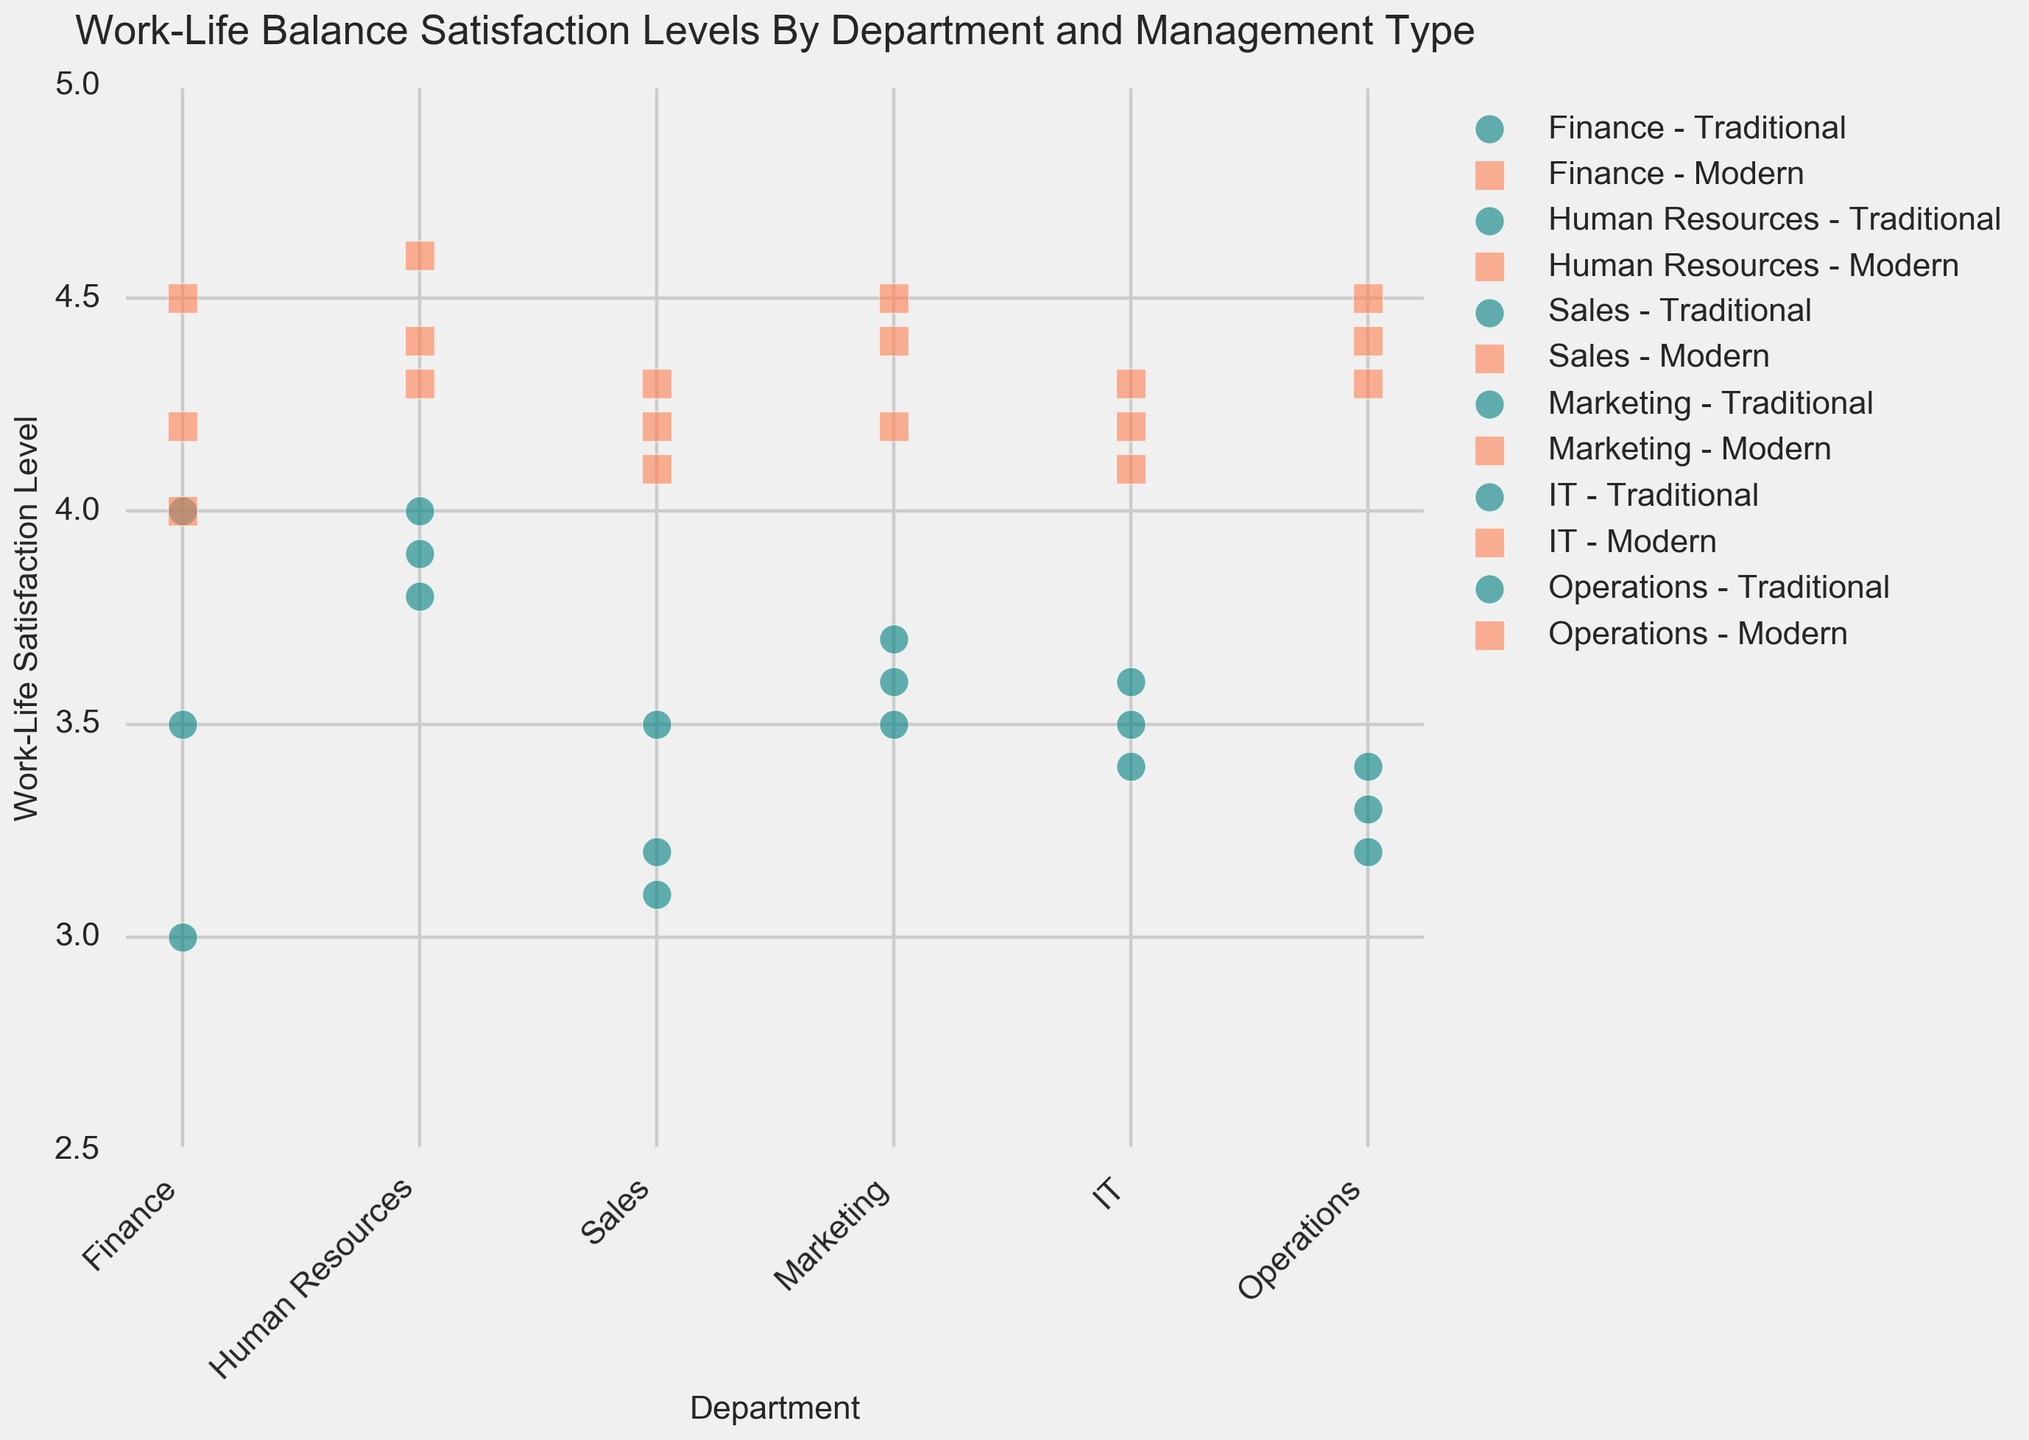Which department shows the highest average Work-Life Satisfaction Level under Modern management? The Finance Department has values of 4.5, 4, and 4.2, averaging 4.23. Human Resources has values 4.6, 4.3, and 4.4, averaging 4.43. Sales has values 4.1, 4.2, and 4.3, averaging 4.2. Marketing has values 4.4, 4.2, and 4.5, averaging 4.37. IT has values 4.2, 4.3, and 4.1, averaging 4.2. Operations has values 4.3, 4.4, and 4.5, averaging 4.4. Hence, Human Resources has the highest average of 4.43
Answer: Human Resources Which department has the greatest difference in Work-Life Satisfaction Levels between Traditional and Modern management types? For Finance: Max (Modern) 4.5 - Min (Traditional) 3 = 1.5, Human Resources: 4.6 - 3.8 = 0.8, Sales: 4.3 - 3.1 = 1.2, Marketing: 4.5 - 3.5 = 1, IT: 4.3 - 3.4 = 0.9, Operations: 4.5 - 3.2 = 1.3. Thus, Finance has the greatest difference of 1.5
Answer: Finance What is the median Work-Life Satisfaction Level for the Sales department under each management type? Traditional: Values are 3.2, 3.5, 3.1; Median is 3.2. Modern: Values are 4.1, 4.2, 4.3; Median is 4.2
Answer: Traditional: 3.2, Modern: 4.2 Which department had the lowest satisfaction level under Modern management? By comparing the satisfaction levels: Finance (4, 4.2, 4.5), Human Resources (4.3, 4.4, 4.6), Sales (4.1, 4.2, 4.3), Marketing (4.2, 4.4, 4.5), IT (4.1, 4.2, 4.3), Operations (4.3, 4.4, 4.5) – Sales with 4.1 being the lowest individual value
Answer: Sales Which management type exhibits a generally higher satisfaction level across departments? Modern management has higher satisfaction levels with values ranging between 4 to 4.5 across departments compared to Traditional management whose values range between 3 to 4
Answer: Modern 